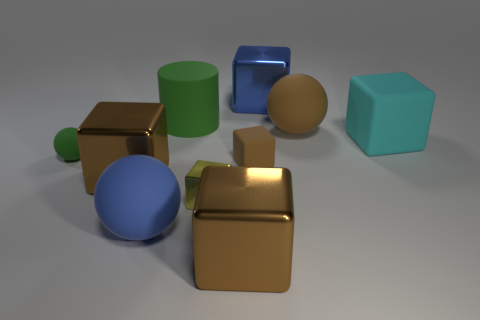Subtract all yellow spheres. How many brown cubes are left? 3 Subtract all yellow blocks. How many blocks are left? 5 Subtract all tiny rubber cubes. How many cubes are left? 5 Subtract all cyan blocks. Subtract all red cylinders. How many blocks are left? 5 Subtract all balls. How many objects are left? 7 Add 6 blue balls. How many blue balls are left? 7 Add 2 brown cubes. How many brown cubes exist? 5 Subtract 0 gray cylinders. How many objects are left? 10 Subtract all large cyan things. Subtract all tiny yellow shiny cubes. How many objects are left? 8 